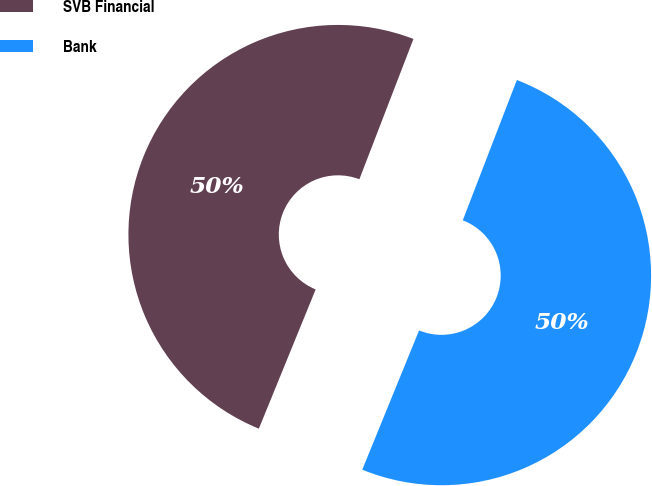Convert chart to OTSL. <chart><loc_0><loc_0><loc_500><loc_500><pie_chart><fcel>SVB Financial<fcel>Bank<nl><fcel>49.69%<fcel>50.31%<nl></chart> 